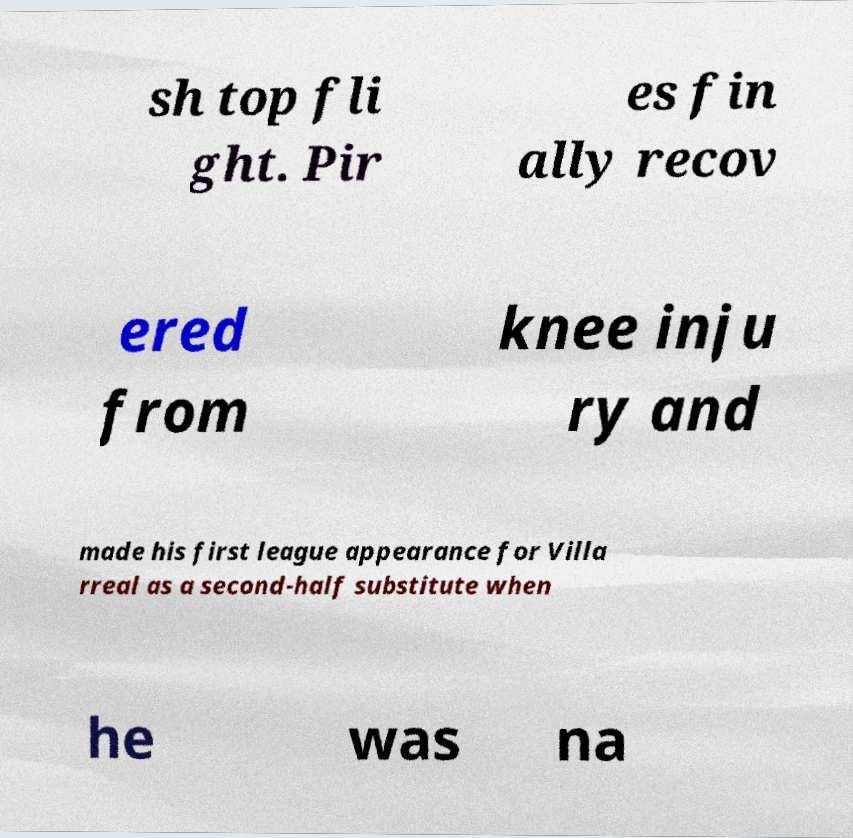Can you accurately transcribe the text from the provided image for me? sh top fli ght. Pir es fin ally recov ered from knee inju ry and made his first league appearance for Villa rreal as a second-half substitute when he was na 